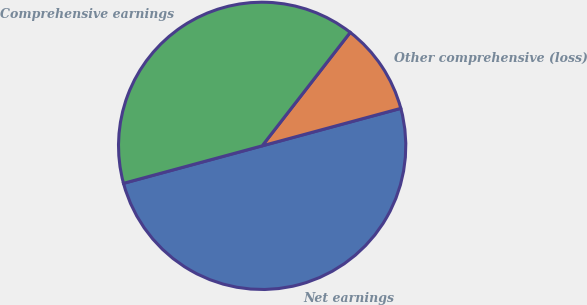Convert chart to OTSL. <chart><loc_0><loc_0><loc_500><loc_500><pie_chart><fcel>Net earnings<fcel>Other comprehensive (loss)<fcel>Comprehensive earnings<nl><fcel>50.0%<fcel>10.29%<fcel>39.71%<nl></chart> 